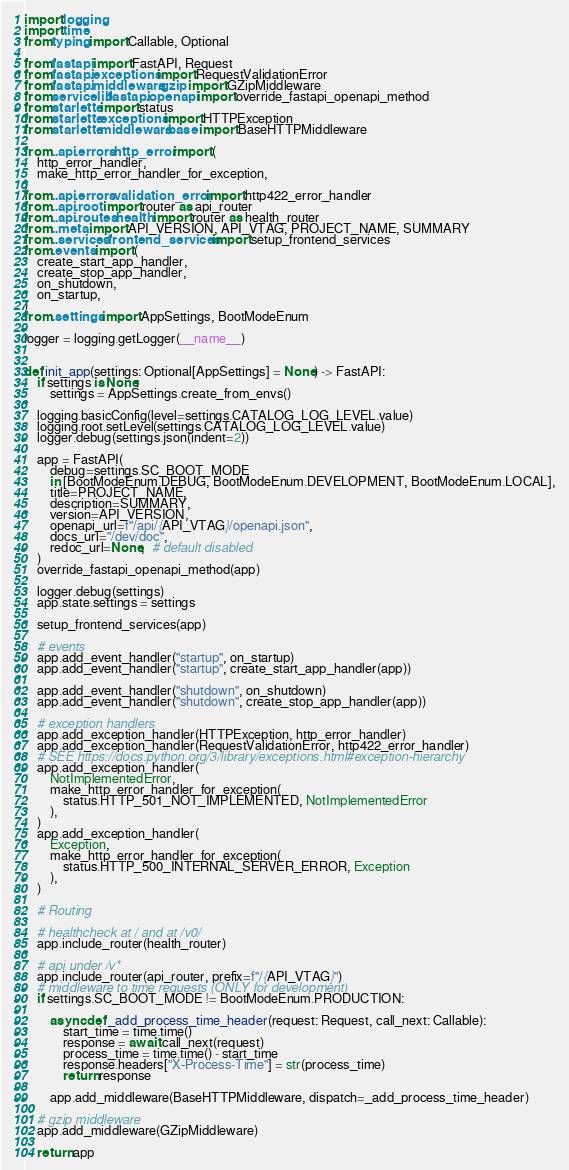<code> <loc_0><loc_0><loc_500><loc_500><_Python_>import logging
import time
from typing import Callable, Optional

from fastapi import FastAPI, Request
from fastapi.exceptions import RequestValidationError
from fastapi.middleware.gzip import GZipMiddleware
from servicelib.fastapi.openapi import override_fastapi_openapi_method
from starlette import status
from starlette.exceptions import HTTPException
from starlette.middleware.base import BaseHTTPMiddleware

from ..api.errors.http_error import (
    http_error_handler,
    make_http_error_handler_for_exception,
)
from ..api.errors.validation_error import http422_error_handler
from ..api.root import router as api_router
from ..api.routes.health import router as health_router
from ..meta import API_VERSION, API_VTAG, PROJECT_NAME, SUMMARY
from ..services.frontend_services import setup_frontend_services
from .events import (
    create_start_app_handler,
    create_stop_app_handler,
    on_shutdown,
    on_startup,
)
from .settings import AppSettings, BootModeEnum

logger = logging.getLogger(__name__)


def init_app(settings: Optional[AppSettings] = None) -> FastAPI:
    if settings is None:
        settings = AppSettings.create_from_envs()

    logging.basicConfig(level=settings.CATALOG_LOG_LEVEL.value)
    logging.root.setLevel(settings.CATALOG_LOG_LEVEL.value)
    logger.debug(settings.json(indent=2))

    app = FastAPI(
        debug=settings.SC_BOOT_MODE
        in [BootModeEnum.DEBUG, BootModeEnum.DEVELOPMENT, BootModeEnum.LOCAL],
        title=PROJECT_NAME,
        description=SUMMARY,
        version=API_VERSION,
        openapi_url=f"/api/{API_VTAG}/openapi.json",
        docs_url="/dev/doc",
        redoc_url=None,  # default disabled
    )
    override_fastapi_openapi_method(app)

    logger.debug(settings)
    app.state.settings = settings

    setup_frontend_services(app)

    # events
    app.add_event_handler("startup", on_startup)
    app.add_event_handler("startup", create_start_app_handler(app))

    app.add_event_handler("shutdown", on_shutdown)
    app.add_event_handler("shutdown", create_stop_app_handler(app))

    # exception handlers
    app.add_exception_handler(HTTPException, http_error_handler)
    app.add_exception_handler(RequestValidationError, http422_error_handler)
    # SEE https://docs.python.org/3/library/exceptions.html#exception-hierarchy
    app.add_exception_handler(
        NotImplementedError,
        make_http_error_handler_for_exception(
            status.HTTP_501_NOT_IMPLEMENTED, NotImplementedError
        ),
    )
    app.add_exception_handler(
        Exception,
        make_http_error_handler_for_exception(
            status.HTTP_500_INTERNAL_SERVER_ERROR, Exception
        ),
    )

    # Routing

    # healthcheck at / and at /v0/
    app.include_router(health_router)

    # api under /v*
    app.include_router(api_router, prefix=f"/{API_VTAG}")
    # middleware to time requests (ONLY for development)
    if settings.SC_BOOT_MODE != BootModeEnum.PRODUCTION:

        async def _add_process_time_header(request: Request, call_next: Callable):
            start_time = time.time()
            response = await call_next(request)
            process_time = time.time() - start_time
            response.headers["X-Process-Time"] = str(process_time)
            return response

        app.add_middleware(BaseHTTPMiddleware, dispatch=_add_process_time_header)

    # gzip middleware
    app.add_middleware(GZipMiddleware)

    return app
</code> 